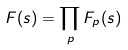Convert formula to latex. <formula><loc_0><loc_0><loc_500><loc_500>F ( s ) = \prod _ { p } F _ { p } ( s )</formula> 